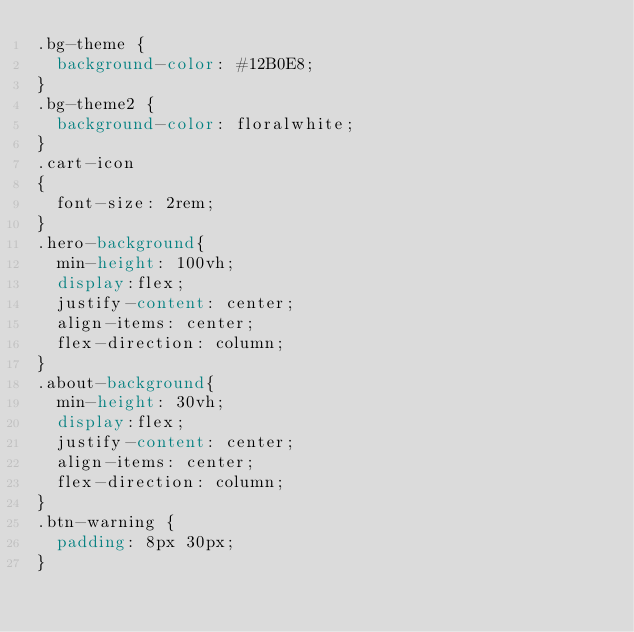<code> <loc_0><loc_0><loc_500><loc_500><_CSS_>.bg-theme {
  background-color: #12B0E8;
}
.bg-theme2 {
  background-color: floralwhite;
}
.cart-icon
{
  font-size: 2rem;
}
.hero-background{
  min-height: 100vh;
  display:flex;
  justify-content: center;
  align-items: center;
  flex-direction: column;
}
.about-background{
  min-height: 30vh;
  display:flex;
  justify-content: center;
  align-items: center;
  flex-direction: column;
}
.btn-warning {
  padding: 8px 30px;
}</code> 